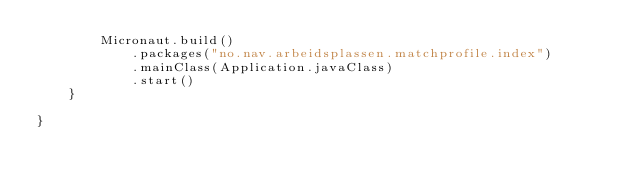Convert code to text. <code><loc_0><loc_0><loc_500><loc_500><_Kotlin_>        Micronaut.build()
            .packages("no.nav.arbeidsplassen.matchprofile.index")
            .mainClass(Application.javaClass)
            .start()
    }

}
</code> 